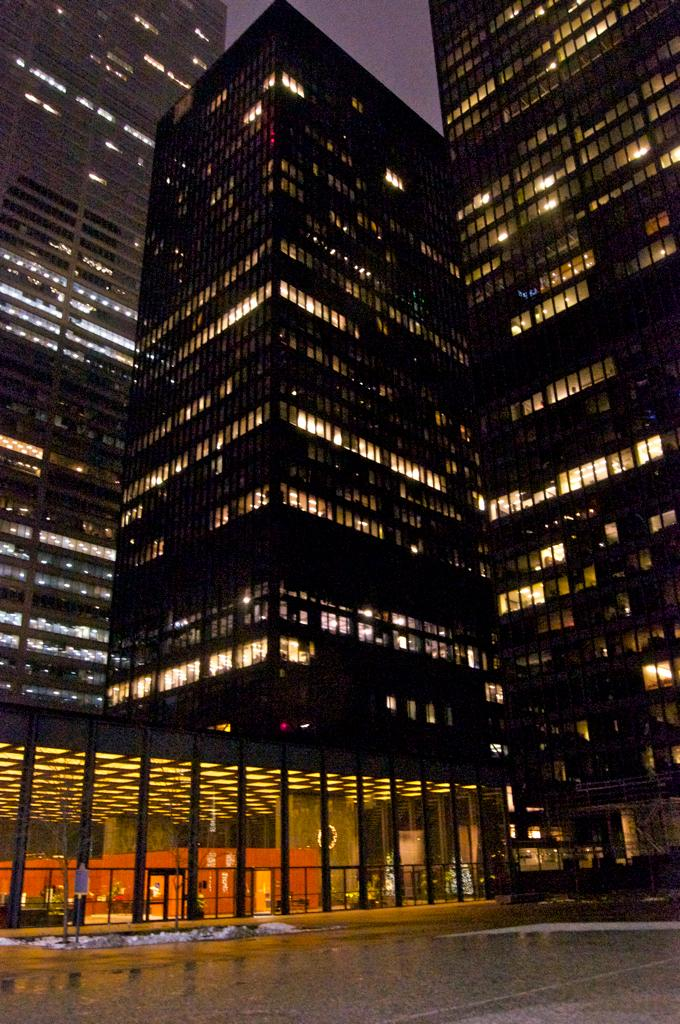What type of structures can be seen in the image? There are buildings in the image. Can you describe any other elements in the image besides the buildings? Yes, there are lights visible in the image. Reasoning: Let' Let's think step by step in order to produce the conversation. We start by identifying the main subject of the image, which is the buildings. Then, we expand the conversation to include other elements that are also visible, such as the lights. Each question is designed to elicit a specific detail about the image that is known from the provided facts. Absurd Question/Answer: What type of whistle can be heard in the image? There is no whistle present in the image, as it is a visual representation and does not include sound. 